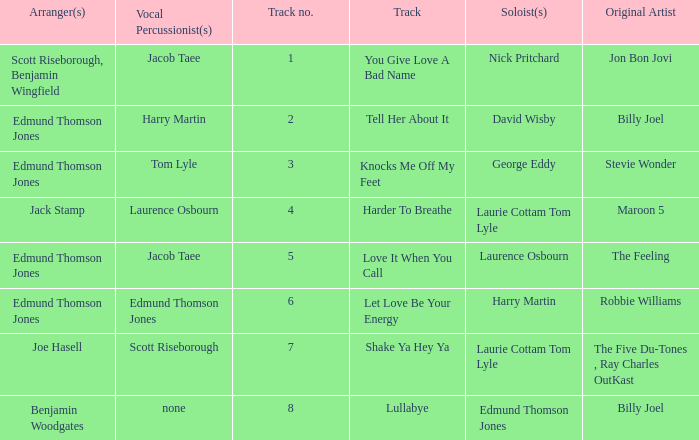Who arranged song(s) with tom lyle on the vocal percussion? Edmund Thomson Jones. 